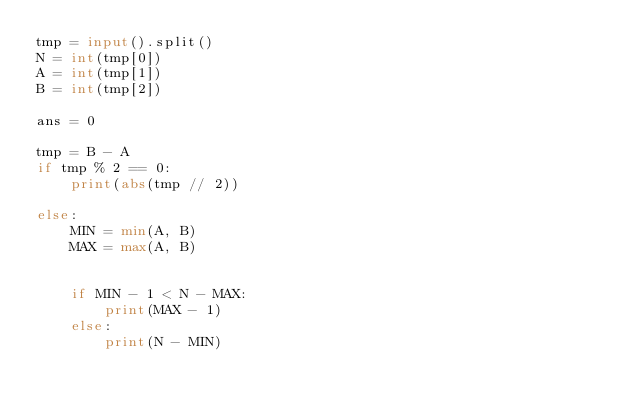Convert code to text. <code><loc_0><loc_0><loc_500><loc_500><_Python_>tmp = input().split()
N = int(tmp[0])
A = int(tmp[1])
B = int(tmp[2])

ans = 0

tmp = B - A
if tmp % 2 == 0:
    print(abs(tmp // 2))
    
else:
    MIN = min(A, B)
    MAX = max(A, B)


    if MIN - 1 < N - MAX:
        print(MAX - 1)
    else:
        print(N - MIN)
</code> 